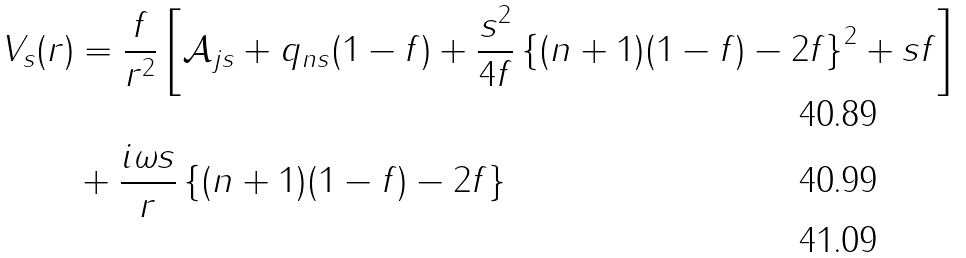Convert formula to latex. <formula><loc_0><loc_0><loc_500><loc_500>V _ { s } ( r ) & = \frac { f } { r ^ { 2 } } \left [ { \mathcal { A } _ { j s } + q _ { n s } ( 1 - f ) + \frac { s ^ { 2 } } { 4 f } \left \{ { ( n + 1 ) ( 1 - f ) - 2 f } \right \} ^ { 2 } + s f } \right ] \\ & + \frac { i \omega s } { r } \left \{ { ( n + 1 ) ( 1 - f ) - 2 f } \right \} \\</formula> 